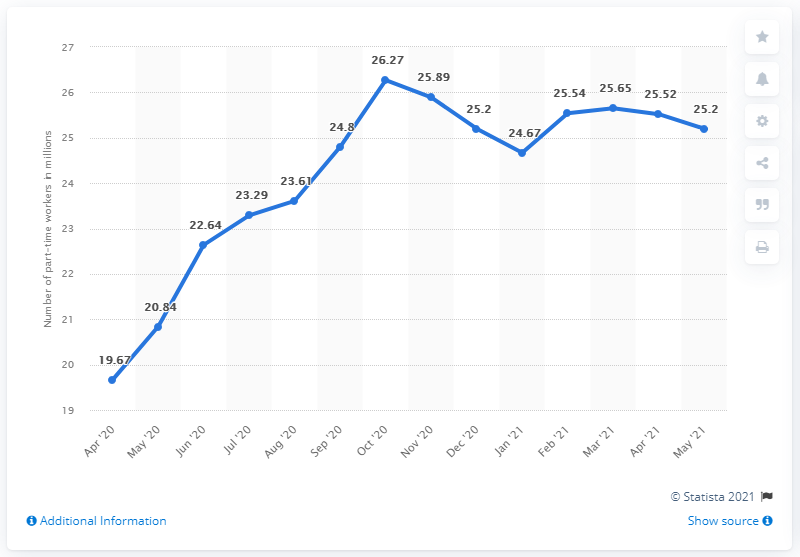Indicate a few pertinent items in this graphic. In May 2021, there were 25.2 million people employed in the United States on a part-time basis. In October 2020, the month with the highest number of part-time workers was recorded. The number of part-time workers between October and April was 6.6%. 